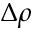<formula> <loc_0><loc_0><loc_500><loc_500>\Delta \rho</formula> 